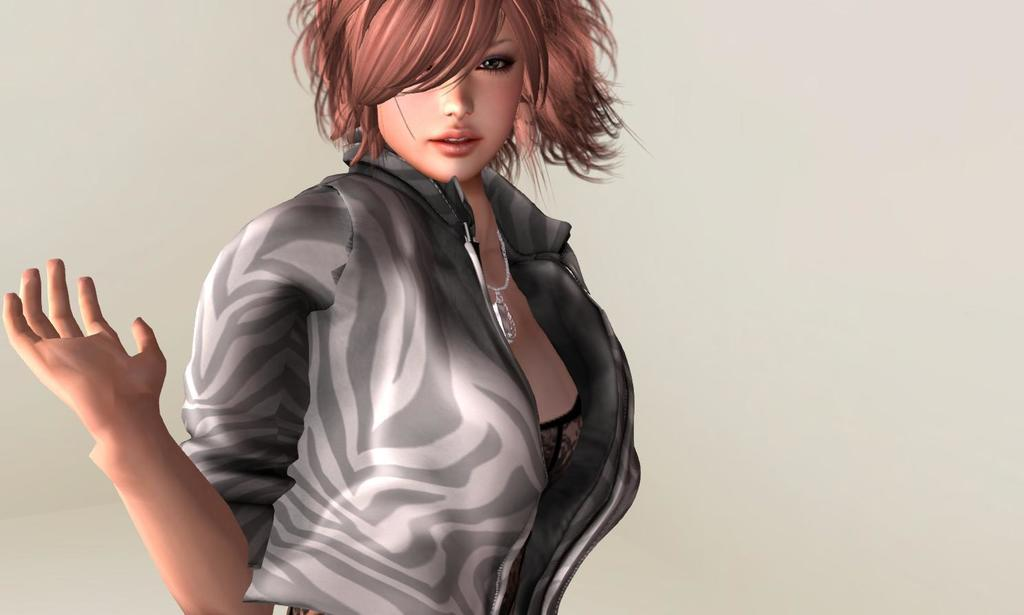What type of image is being described? The image is an animated picture. Can you describe the person in the image? There is a woman in the image. What is the woman wearing? The woman is wearing a grey jacket. What is the woman doing in the image? The woman is standing. What is the background of the image? There is a white background in the image. What type of wrench is the woman using in the image? There is no wrench present in the image. Is the woman in jail in the image? There is no indication of a jail or any confinement in the image. 